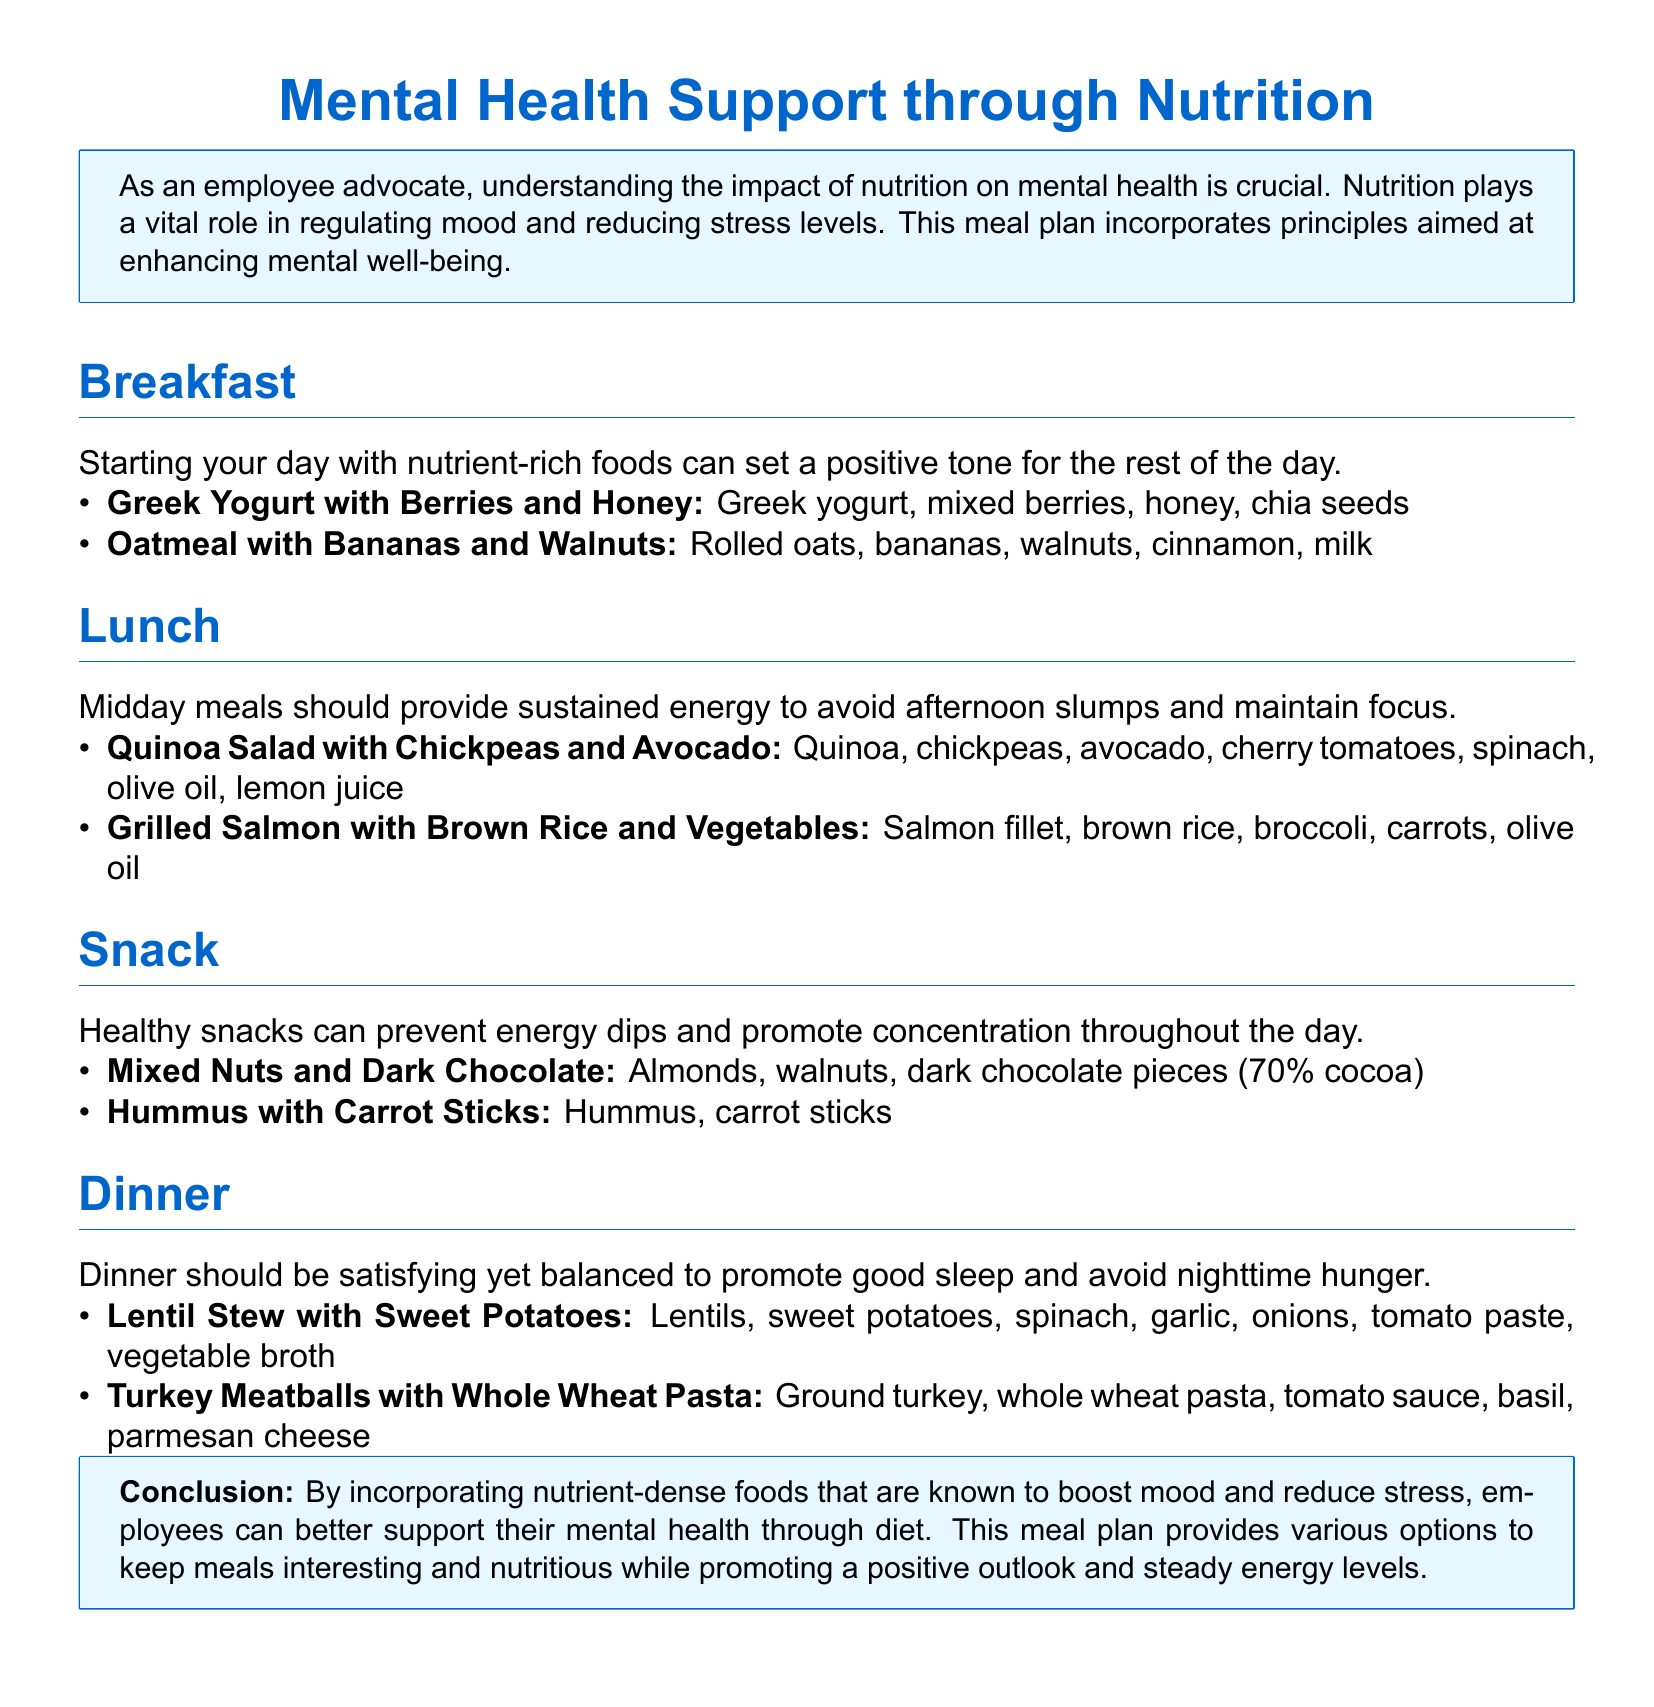What are two breakfast options listed? The breakfast section includes two options: Greek Yogurt with Berries and Honey, and Oatmeal with Bananas and Walnuts.
Answer: Greek Yogurt with Berries and Honey; Oatmeal with Bananas and Walnuts Which ingredient is common in both lunch options? Both lunch options include ingredients that are known for their health benefits; salmon is a key one that's high in omega-3 fatty acids.
Answer: Salmon What type of nuts are included in the snack options? The snack options include mixed nuts which specifically list almonds and walnuts.
Answer: Almonds; Walnuts How many ingredients does the Lentil Stew have? The Lentil Stew option lists six ingredients: Lentils, sweet potatoes, spinach, garlic, onions, and tomato paste.
Answer: Six What is the purpose of the meal plan? The meal plan's goal is to support mental health through nutrition by providing mood-boosting and stress-reducing foods.
Answer: To support mental health through nutrition What type of meal is mentioned for dinner? The dinner section contains two specific meal options, with one being Turkey Meatballs with Whole Wheat Pasta.
Answer: Turkey Meatballs with Whole Wheat Pasta What is a key benefit of consuming snacks listed in the document? The document states that healthy snacks can prevent energy dips and promote concentration throughout the day.
Answer: Prevent energy dips; Promote concentration Which ingredient is used in both the breakfast and dinner recipes? Greek yogurt is not present in the dinner options; however, both meals utilize common ingredients like spinach, which is present in the Lentil Stew.
Answer: Spinach 